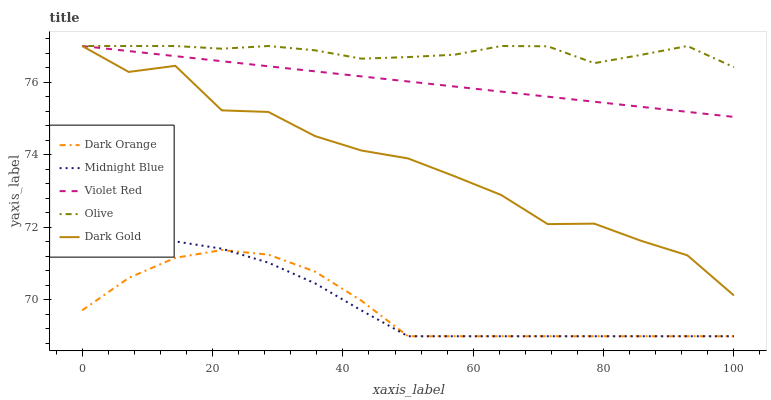Does Dark Orange have the minimum area under the curve?
Answer yes or no. Yes. Does Olive have the maximum area under the curve?
Answer yes or no. Yes. Does Violet Red have the minimum area under the curve?
Answer yes or no. No. Does Violet Red have the maximum area under the curve?
Answer yes or no. No. Is Violet Red the smoothest?
Answer yes or no. Yes. Is Dark Gold the roughest?
Answer yes or no. Yes. Is Dark Orange the smoothest?
Answer yes or no. No. Is Dark Orange the roughest?
Answer yes or no. No. Does Dark Orange have the lowest value?
Answer yes or no. Yes. Does Violet Red have the lowest value?
Answer yes or no. No. Does Dark Gold have the highest value?
Answer yes or no. Yes. Does Dark Orange have the highest value?
Answer yes or no. No. Is Dark Orange less than Olive?
Answer yes or no. Yes. Is Violet Red greater than Midnight Blue?
Answer yes or no. Yes. Does Olive intersect Violet Red?
Answer yes or no. Yes. Is Olive less than Violet Red?
Answer yes or no. No. Is Olive greater than Violet Red?
Answer yes or no. No. Does Dark Orange intersect Olive?
Answer yes or no. No. 